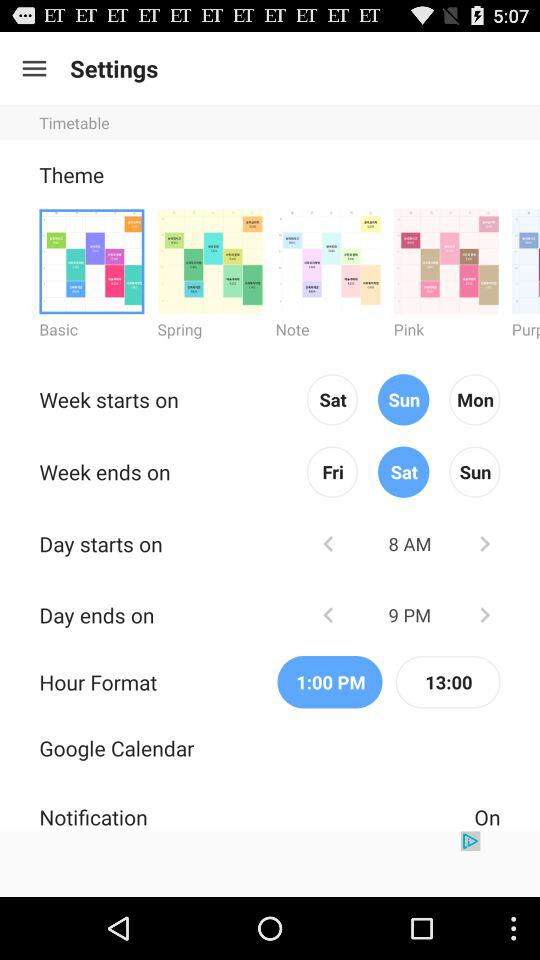When does the week start? The week starts on Sunday. 